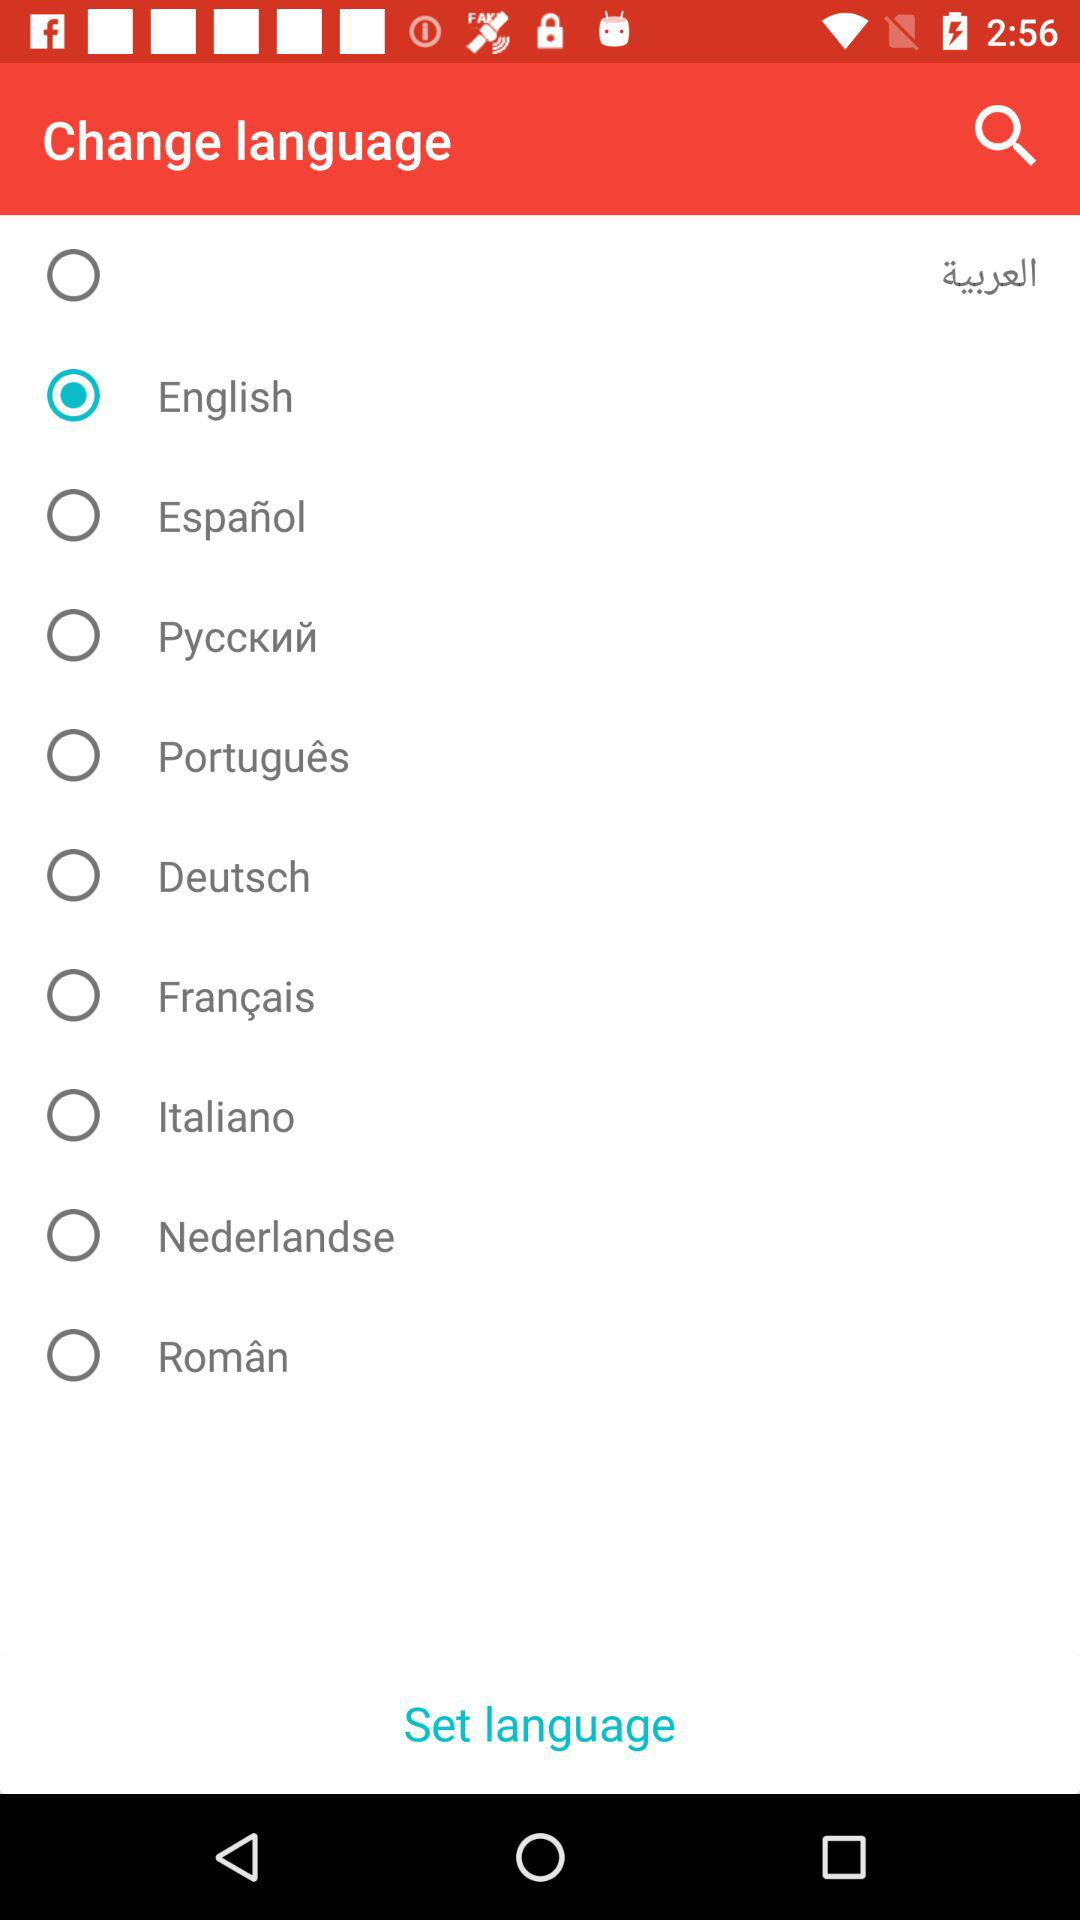Which language has been selected? The selected language is English. 